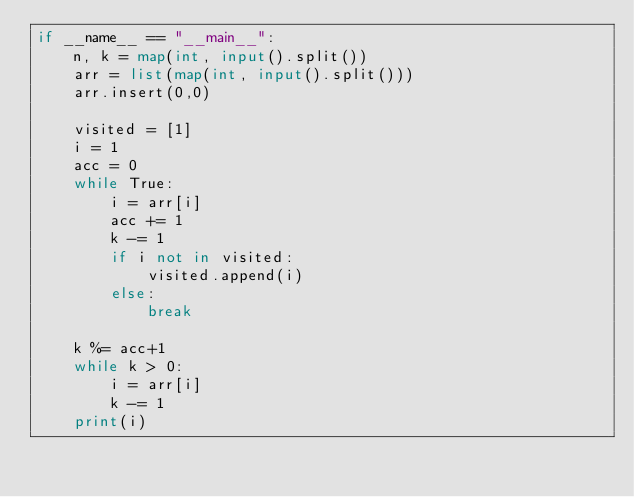Convert code to text. <code><loc_0><loc_0><loc_500><loc_500><_Python_>if __name__ == "__main__":
    n, k = map(int, input().split())
    arr = list(map(int, input().split()))
    arr.insert(0,0)

    visited = [1]
    i = 1
    acc = 0
    while True:
        i = arr[i]
        acc += 1
        k -= 1
        if i not in visited:
            visited.append(i)
        else:
            break
        
    k %= acc+1
    while k > 0:
        i = arr[i]
        k -= 1
    print(i)
</code> 